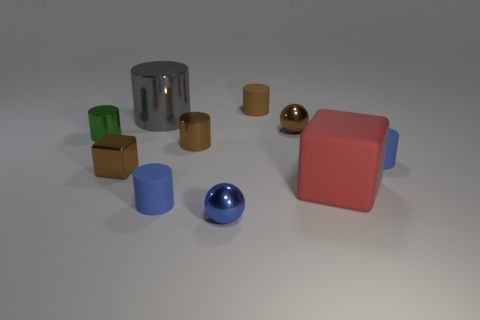What number of balls are either tiny shiny objects or small brown metal things?
Your answer should be very brief. 2. How many other objects are there of the same material as the blue ball?
Make the answer very short. 5. The metal object in front of the large red thing has what shape?
Ensure brevity in your answer.  Sphere. What is the blue thing behind the small matte cylinder in front of the large red rubber thing made of?
Give a very brief answer. Rubber. Are there more small matte cylinders behind the small brown block than large green rubber things?
Make the answer very short. Yes. What number of other objects are the same color as the large cube?
Make the answer very short. 0. There is a blue metallic object that is the same size as the green cylinder; what is its shape?
Make the answer very short. Sphere. There is a blue rubber cylinder that is on the right side of the brown metallic object that is right of the brown rubber cylinder; how many blue spheres are behind it?
Make the answer very short. 0. What number of metallic objects are large cylinders or big green blocks?
Keep it short and to the point. 1. The metallic object that is both behind the small green metal thing and right of the large gray cylinder is what color?
Ensure brevity in your answer.  Brown. 